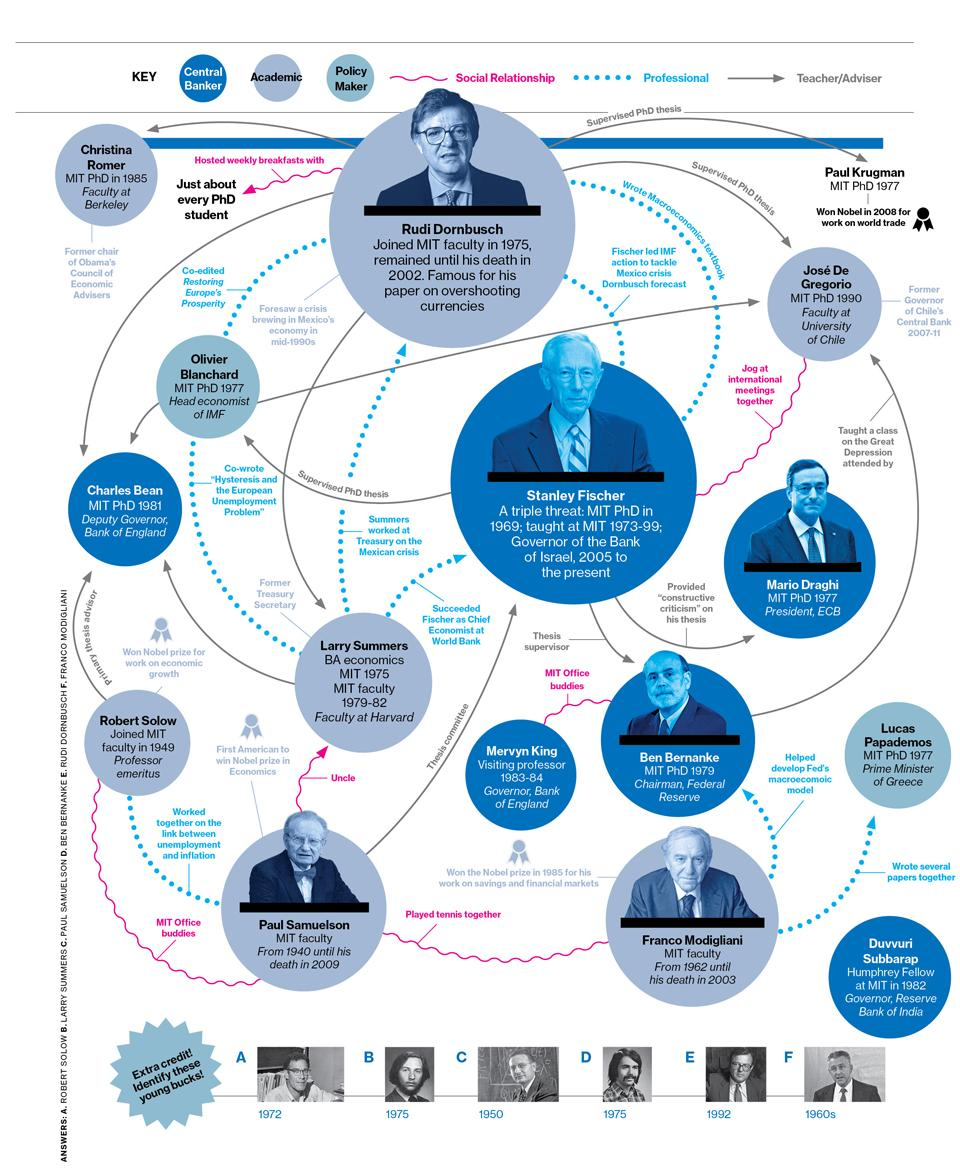Give some essential details in this illustration. The infographic contains two policy makers. Charles Bean's policy maker is Olivier Blanchard. Larry Summers's uncle is Paul Samuelson. Franco Modigliani was a faculty member at MIT from 1962 until his death in 2003, and during that time, he made significant contributions to the field of economics. 